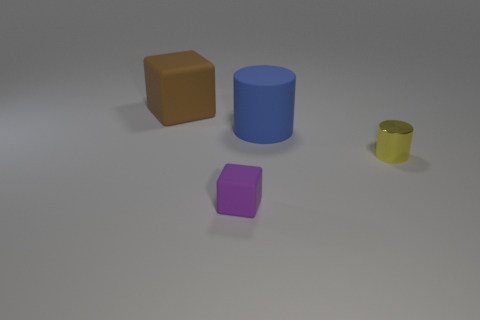Do the big rubber block and the big matte cylinder have the same color?
Offer a terse response. No. Is the number of large rubber things behind the large rubber cube less than the number of tiny purple rubber cubes to the left of the yellow cylinder?
Provide a short and direct response. Yes. The other matte thing that is the same shape as the small yellow object is what color?
Keep it short and to the point. Blue. Do the object in front of the yellow object and the small yellow metallic cylinder have the same size?
Offer a very short reply. Yes. Are there fewer rubber things behind the small purple matte object than tiny purple metal cubes?
Your response must be concise. No. Are there any other things that have the same size as the brown rubber block?
Your answer should be compact. Yes. There is a rubber block that is on the left side of the rubber cube that is in front of the large brown matte block; what size is it?
Offer a terse response. Large. Is there anything else that has the same shape as the purple object?
Make the answer very short. Yes. Is the number of blue metallic spheres less than the number of yellow shiny objects?
Keep it short and to the point. Yes. What is the material of the thing that is to the left of the shiny cylinder and in front of the large blue matte object?
Keep it short and to the point. Rubber. 